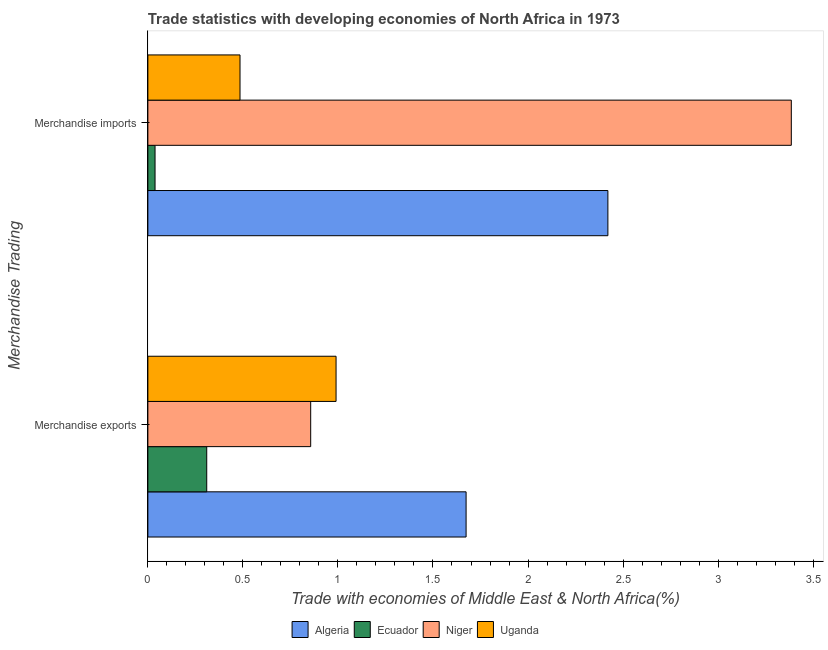How many different coloured bars are there?
Provide a succinct answer. 4. How many groups of bars are there?
Provide a short and direct response. 2. Are the number of bars per tick equal to the number of legend labels?
Keep it short and to the point. Yes. Are the number of bars on each tick of the Y-axis equal?
Provide a short and direct response. Yes. How many bars are there on the 2nd tick from the bottom?
Offer a very short reply. 4. What is the merchandise exports in Algeria?
Provide a short and direct response. 1.67. Across all countries, what is the maximum merchandise exports?
Give a very brief answer. 1.67. Across all countries, what is the minimum merchandise imports?
Your response must be concise. 0.04. In which country was the merchandise imports maximum?
Give a very brief answer. Niger. In which country was the merchandise exports minimum?
Ensure brevity in your answer.  Ecuador. What is the total merchandise imports in the graph?
Offer a terse response. 6.33. What is the difference between the merchandise imports in Niger and that in Ecuador?
Your answer should be compact. 3.35. What is the difference between the merchandise exports in Niger and the merchandise imports in Algeria?
Offer a terse response. -1.56. What is the average merchandise imports per country?
Provide a short and direct response. 1.58. What is the difference between the merchandise imports and merchandise exports in Algeria?
Offer a very short reply. 0.75. What is the ratio of the merchandise exports in Ecuador to that in Uganda?
Offer a terse response. 0.31. Is the merchandise imports in Algeria less than that in Uganda?
Ensure brevity in your answer.  No. What does the 3rd bar from the top in Merchandise exports represents?
Your answer should be compact. Ecuador. What does the 1st bar from the bottom in Merchandise exports represents?
Ensure brevity in your answer.  Algeria. How many countries are there in the graph?
Provide a short and direct response. 4. What is the difference between two consecutive major ticks on the X-axis?
Provide a succinct answer. 0.5. Where does the legend appear in the graph?
Provide a succinct answer. Bottom center. How many legend labels are there?
Provide a succinct answer. 4. What is the title of the graph?
Your answer should be very brief. Trade statistics with developing economies of North Africa in 1973. Does "Switzerland" appear as one of the legend labels in the graph?
Make the answer very short. No. What is the label or title of the X-axis?
Your response must be concise. Trade with economies of Middle East & North Africa(%). What is the label or title of the Y-axis?
Give a very brief answer. Merchandise Trading. What is the Trade with economies of Middle East & North Africa(%) of Algeria in Merchandise exports?
Provide a succinct answer. 1.67. What is the Trade with economies of Middle East & North Africa(%) of Ecuador in Merchandise exports?
Your answer should be compact. 0.31. What is the Trade with economies of Middle East & North Africa(%) of Niger in Merchandise exports?
Your answer should be compact. 0.86. What is the Trade with economies of Middle East & North Africa(%) of Uganda in Merchandise exports?
Give a very brief answer. 0.99. What is the Trade with economies of Middle East & North Africa(%) in Algeria in Merchandise imports?
Offer a terse response. 2.42. What is the Trade with economies of Middle East & North Africa(%) in Ecuador in Merchandise imports?
Your answer should be compact. 0.04. What is the Trade with economies of Middle East & North Africa(%) in Niger in Merchandise imports?
Keep it short and to the point. 3.39. What is the Trade with economies of Middle East & North Africa(%) of Uganda in Merchandise imports?
Your answer should be compact. 0.48. Across all Merchandise Trading, what is the maximum Trade with economies of Middle East & North Africa(%) of Algeria?
Give a very brief answer. 2.42. Across all Merchandise Trading, what is the maximum Trade with economies of Middle East & North Africa(%) of Ecuador?
Your answer should be compact. 0.31. Across all Merchandise Trading, what is the maximum Trade with economies of Middle East & North Africa(%) of Niger?
Give a very brief answer. 3.39. Across all Merchandise Trading, what is the maximum Trade with economies of Middle East & North Africa(%) in Uganda?
Make the answer very short. 0.99. Across all Merchandise Trading, what is the minimum Trade with economies of Middle East & North Africa(%) of Algeria?
Offer a terse response. 1.67. Across all Merchandise Trading, what is the minimum Trade with economies of Middle East & North Africa(%) of Ecuador?
Ensure brevity in your answer.  0.04. Across all Merchandise Trading, what is the minimum Trade with economies of Middle East & North Africa(%) of Niger?
Give a very brief answer. 0.86. Across all Merchandise Trading, what is the minimum Trade with economies of Middle East & North Africa(%) of Uganda?
Provide a short and direct response. 0.48. What is the total Trade with economies of Middle East & North Africa(%) in Algeria in the graph?
Provide a short and direct response. 4.09. What is the total Trade with economies of Middle East & North Africa(%) of Ecuador in the graph?
Make the answer very short. 0.35. What is the total Trade with economies of Middle East & North Africa(%) of Niger in the graph?
Ensure brevity in your answer.  4.24. What is the total Trade with economies of Middle East & North Africa(%) of Uganda in the graph?
Your response must be concise. 1.47. What is the difference between the Trade with economies of Middle East & North Africa(%) of Algeria in Merchandise exports and that in Merchandise imports?
Provide a succinct answer. -0.75. What is the difference between the Trade with economies of Middle East & North Africa(%) in Ecuador in Merchandise exports and that in Merchandise imports?
Offer a terse response. 0.27. What is the difference between the Trade with economies of Middle East & North Africa(%) of Niger in Merchandise exports and that in Merchandise imports?
Offer a very short reply. -2.53. What is the difference between the Trade with economies of Middle East & North Africa(%) in Uganda in Merchandise exports and that in Merchandise imports?
Give a very brief answer. 0.51. What is the difference between the Trade with economies of Middle East & North Africa(%) in Algeria in Merchandise exports and the Trade with economies of Middle East & North Africa(%) in Ecuador in Merchandise imports?
Your response must be concise. 1.64. What is the difference between the Trade with economies of Middle East & North Africa(%) in Algeria in Merchandise exports and the Trade with economies of Middle East & North Africa(%) in Niger in Merchandise imports?
Your response must be concise. -1.71. What is the difference between the Trade with economies of Middle East & North Africa(%) in Algeria in Merchandise exports and the Trade with economies of Middle East & North Africa(%) in Uganda in Merchandise imports?
Your answer should be compact. 1.19. What is the difference between the Trade with economies of Middle East & North Africa(%) in Ecuador in Merchandise exports and the Trade with economies of Middle East & North Africa(%) in Niger in Merchandise imports?
Your response must be concise. -3.08. What is the difference between the Trade with economies of Middle East & North Africa(%) in Ecuador in Merchandise exports and the Trade with economies of Middle East & North Africa(%) in Uganda in Merchandise imports?
Make the answer very short. -0.18. What is the difference between the Trade with economies of Middle East & North Africa(%) in Niger in Merchandise exports and the Trade with economies of Middle East & North Africa(%) in Uganda in Merchandise imports?
Your answer should be compact. 0.37. What is the average Trade with economies of Middle East & North Africa(%) of Algeria per Merchandise Trading?
Make the answer very short. 2.05. What is the average Trade with economies of Middle East & North Africa(%) of Ecuador per Merchandise Trading?
Your response must be concise. 0.17. What is the average Trade with economies of Middle East & North Africa(%) in Niger per Merchandise Trading?
Offer a very short reply. 2.12. What is the average Trade with economies of Middle East & North Africa(%) in Uganda per Merchandise Trading?
Make the answer very short. 0.74. What is the difference between the Trade with economies of Middle East & North Africa(%) in Algeria and Trade with economies of Middle East & North Africa(%) in Ecuador in Merchandise exports?
Provide a succinct answer. 1.36. What is the difference between the Trade with economies of Middle East & North Africa(%) in Algeria and Trade with economies of Middle East & North Africa(%) in Niger in Merchandise exports?
Provide a succinct answer. 0.82. What is the difference between the Trade with economies of Middle East & North Africa(%) of Algeria and Trade with economies of Middle East & North Africa(%) of Uganda in Merchandise exports?
Provide a short and direct response. 0.68. What is the difference between the Trade with economies of Middle East & North Africa(%) of Ecuador and Trade with economies of Middle East & North Africa(%) of Niger in Merchandise exports?
Provide a succinct answer. -0.55. What is the difference between the Trade with economies of Middle East & North Africa(%) in Ecuador and Trade with economies of Middle East & North Africa(%) in Uganda in Merchandise exports?
Ensure brevity in your answer.  -0.68. What is the difference between the Trade with economies of Middle East & North Africa(%) of Niger and Trade with economies of Middle East & North Africa(%) of Uganda in Merchandise exports?
Give a very brief answer. -0.13. What is the difference between the Trade with economies of Middle East & North Africa(%) of Algeria and Trade with economies of Middle East & North Africa(%) of Ecuador in Merchandise imports?
Keep it short and to the point. 2.38. What is the difference between the Trade with economies of Middle East & North Africa(%) in Algeria and Trade with economies of Middle East & North Africa(%) in Niger in Merchandise imports?
Your answer should be very brief. -0.96. What is the difference between the Trade with economies of Middle East & North Africa(%) of Algeria and Trade with economies of Middle East & North Africa(%) of Uganda in Merchandise imports?
Make the answer very short. 1.94. What is the difference between the Trade with economies of Middle East & North Africa(%) in Ecuador and Trade with economies of Middle East & North Africa(%) in Niger in Merchandise imports?
Provide a succinct answer. -3.35. What is the difference between the Trade with economies of Middle East & North Africa(%) of Ecuador and Trade with economies of Middle East & North Africa(%) of Uganda in Merchandise imports?
Ensure brevity in your answer.  -0.45. What is the difference between the Trade with economies of Middle East & North Africa(%) of Niger and Trade with economies of Middle East & North Africa(%) of Uganda in Merchandise imports?
Make the answer very short. 2.9. What is the ratio of the Trade with economies of Middle East & North Africa(%) of Algeria in Merchandise exports to that in Merchandise imports?
Make the answer very short. 0.69. What is the ratio of the Trade with economies of Middle East & North Africa(%) of Ecuador in Merchandise exports to that in Merchandise imports?
Offer a terse response. 8.2. What is the ratio of the Trade with economies of Middle East & North Africa(%) of Niger in Merchandise exports to that in Merchandise imports?
Your answer should be very brief. 0.25. What is the ratio of the Trade with economies of Middle East & North Africa(%) in Uganda in Merchandise exports to that in Merchandise imports?
Give a very brief answer. 2.04. What is the difference between the highest and the second highest Trade with economies of Middle East & North Africa(%) in Algeria?
Offer a terse response. 0.75. What is the difference between the highest and the second highest Trade with economies of Middle East & North Africa(%) in Ecuador?
Your answer should be compact. 0.27. What is the difference between the highest and the second highest Trade with economies of Middle East & North Africa(%) of Niger?
Provide a succinct answer. 2.53. What is the difference between the highest and the second highest Trade with economies of Middle East & North Africa(%) of Uganda?
Your answer should be very brief. 0.51. What is the difference between the highest and the lowest Trade with economies of Middle East & North Africa(%) of Algeria?
Provide a short and direct response. 0.75. What is the difference between the highest and the lowest Trade with economies of Middle East & North Africa(%) of Ecuador?
Your response must be concise. 0.27. What is the difference between the highest and the lowest Trade with economies of Middle East & North Africa(%) of Niger?
Your answer should be compact. 2.53. What is the difference between the highest and the lowest Trade with economies of Middle East & North Africa(%) in Uganda?
Make the answer very short. 0.51. 